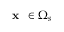Convert formula to latex. <formula><loc_0><loc_0><loc_500><loc_500>x \in \Omega _ { s }</formula> 